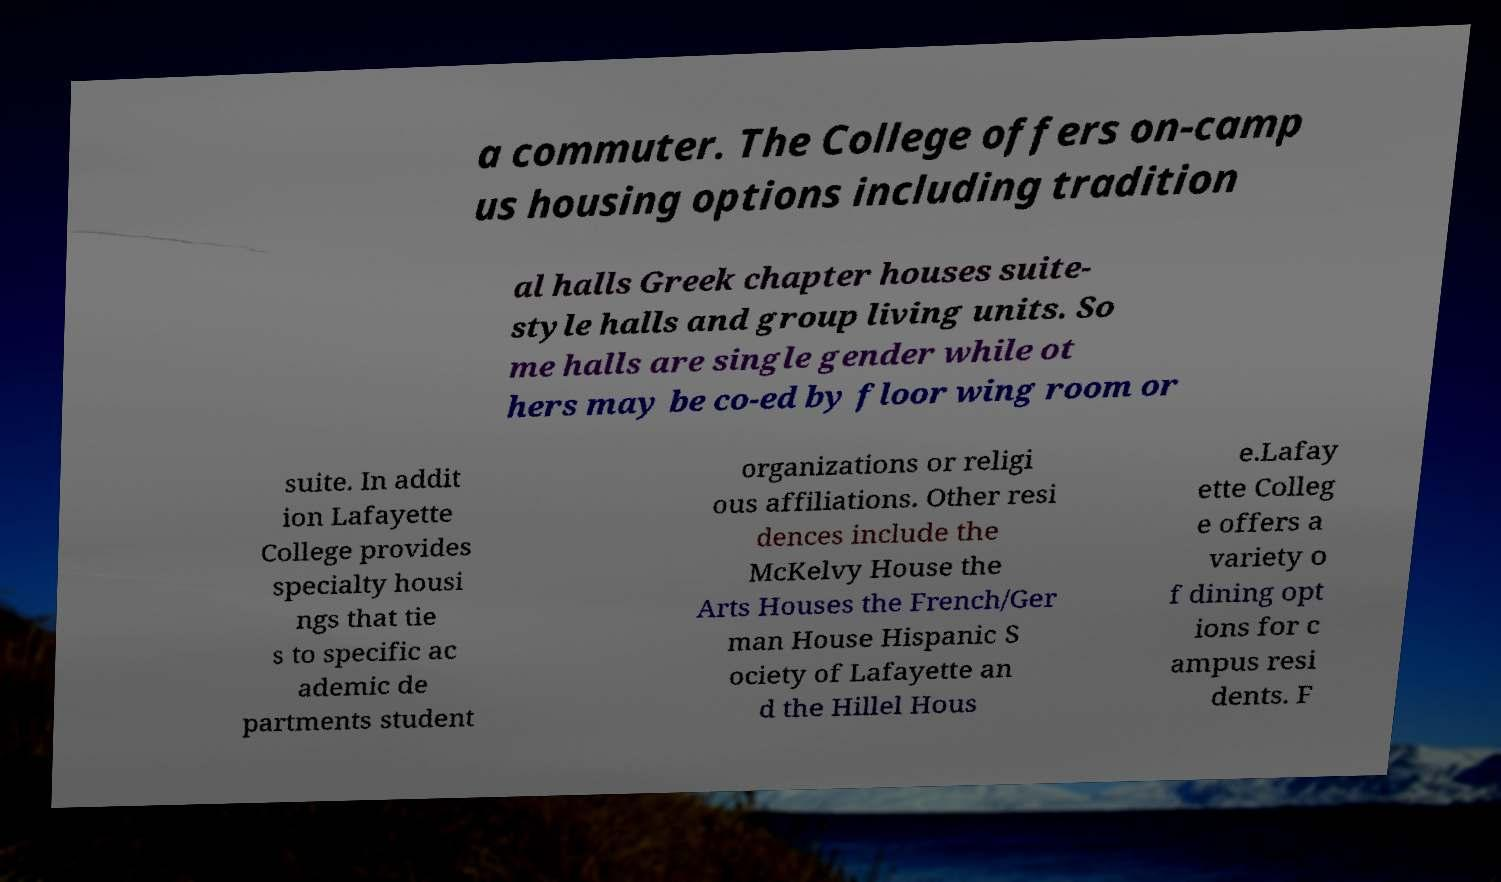Could you assist in decoding the text presented in this image and type it out clearly? a commuter. The College offers on-camp us housing options including tradition al halls Greek chapter houses suite- style halls and group living units. So me halls are single gender while ot hers may be co-ed by floor wing room or suite. In addit ion Lafayette College provides specialty housi ngs that tie s to specific ac ademic de partments student organizations or religi ous affiliations. Other resi dences include the McKelvy House the Arts Houses the French/Ger man House Hispanic S ociety of Lafayette an d the Hillel Hous e.Lafay ette Colleg e offers a variety o f dining opt ions for c ampus resi dents. F 